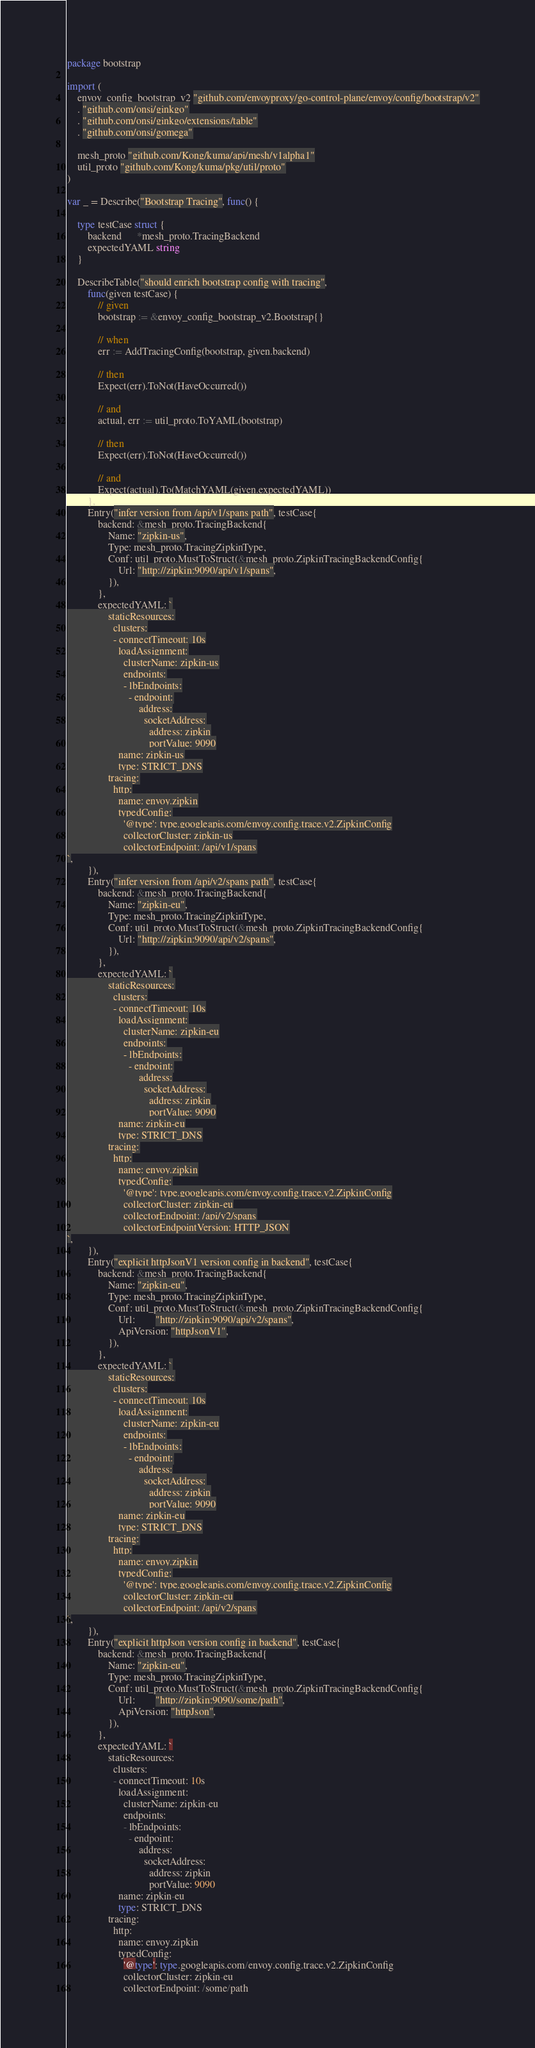Convert code to text. <code><loc_0><loc_0><loc_500><loc_500><_Go_>package bootstrap

import (
	envoy_config_bootstrap_v2 "github.com/envoyproxy/go-control-plane/envoy/config/bootstrap/v2"
	. "github.com/onsi/ginkgo"
	. "github.com/onsi/ginkgo/extensions/table"
	. "github.com/onsi/gomega"

	mesh_proto "github.com/Kong/kuma/api/mesh/v1alpha1"
	util_proto "github.com/Kong/kuma/pkg/util/proto"
)

var _ = Describe("Bootstrap Tracing", func() {

	type testCase struct {
		backend      *mesh_proto.TracingBackend
		expectedYAML string
	}

	DescribeTable("should enrich bootstrap config with tracing",
		func(given testCase) {
			// given
			bootstrap := &envoy_config_bootstrap_v2.Bootstrap{}

			// when
			err := AddTracingConfig(bootstrap, given.backend)

			// then
			Expect(err).ToNot(HaveOccurred())

			// and
			actual, err := util_proto.ToYAML(bootstrap)

			// then
			Expect(err).ToNot(HaveOccurred())

			// and
			Expect(actual).To(MatchYAML(given.expectedYAML))
		},
		Entry("infer version from /api/v1/spans path", testCase{
			backend: &mesh_proto.TracingBackend{
				Name: "zipkin-us",
				Type: mesh_proto.TracingZipkinType,
				Conf: util_proto.MustToStruct(&mesh_proto.ZipkinTracingBackendConfig{
					Url: "http://zipkin:9090/api/v1/spans",
				}),
			},
			expectedYAML: `
                staticResources:
                  clusters:
                  - connectTimeout: 10s
                    loadAssignment:
                      clusterName: zipkin-us
                      endpoints:
                      - lbEndpoints:
                        - endpoint:
                            address:
                              socketAddress:
                                address: zipkin
                                portValue: 9090
                    name: zipkin-us
                    type: STRICT_DNS
                tracing:
                  http:
                    name: envoy.zipkin
                    typedConfig:
                      '@type': type.googleapis.com/envoy.config.trace.v2.ZipkinConfig
                      collectorCluster: zipkin-us
                      collectorEndpoint: /api/v1/spans
`,
		}),
		Entry("infer version from /api/v2/spans path", testCase{
			backend: &mesh_proto.TracingBackend{
				Name: "zipkin-eu",
				Type: mesh_proto.TracingZipkinType,
				Conf: util_proto.MustToStruct(&mesh_proto.ZipkinTracingBackendConfig{
					Url: "http://zipkin:9090/api/v2/spans",
				}),
			},
			expectedYAML: `
                staticResources:
                  clusters:
                  - connectTimeout: 10s
                    loadAssignment:
                      clusterName: zipkin-eu
                      endpoints:
                      - lbEndpoints:
                        - endpoint:
                            address:
                              socketAddress:
                                address: zipkin
                                portValue: 9090
                    name: zipkin-eu
                    type: STRICT_DNS
                tracing:
                  http:
                    name: envoy.zipkin
                    typedConfig:
                      '@type': type.googleapis.com/envoy.config.trace.v2.ZipkinConfig
                      collectorCluster: zipkin-eu
                      collectorEndpoint: /api/v2/spans
                      collectorEndpointVersion: HTTP_JSON
`,
		}),
		Entry("explicit httpJsonV1 version config in backend", testCase{
			backend: &mesh_proto.TracingBackend{
				Name: "zipkin-eu",
				Type: mesh_proto.TracingZipkinType,
				Conf: util_proto.MustToStruct(&mesh_proto.ZipkinTracingBackendConfig{
					Url:        "http://zipkin:9090/api/v2/spans",
					ApiVersion: "httpJsonV1",
				}),
			},
			expectedYAML: `
                staticResources:
                  clusters:
                  - connectTimeout: 10s
                    loadAssignment:
                      clusterName: zipkin-eu
                      endpoints:
                      - lbEndpoints:
                        - endpoint:
                            address:
                              socketAddress:
                                address: zipkin
                                portValue: 9090
                    name: zipkin-eu
                    type: STRICT_DNS
                tracing:
                  http:
                    name: envoy.zipkin
                    typedConfig:
                      '@type': type.googleapis.com/envoy.config.trace.v2.ZipkinConfig
                      collectorCluster: zipkin-eu
                      collectorEndpoint: /api/v2/spans
`,
		}),
		Entry("explicit httpJson version config in backend", testCase{
			backend: &mesh_proto.TracingBackend{
				Name: "zipkin-eu",
				Type: mesh_proto.TracingZipkinType,
				Conf: util_proto.MustToStruct(&mesh_proto.ZipkinTracingBackendConfig{
					Url:        "http://zipkin:9090/some/path",
					ApiVersion: "httpJson",
				}),
			},
			expectedYAML: `
                staticResources:
                  clusters:
                  - connectTimeout: 10s
                    loadAssignment:
                      clusterName: zipkin-eu
                      endpoints:
                      - lbEndpoints:
                        - endpoint:
                            address:
                              socketAddress:
                                address: zipkin
                                portValue: 9090
                    name: zipkin-eu
                    type: STRICT_DNS
                tracing:
                  http:
                    name: envoy.zipkin
                    typedConfig:
                      '@type': type.googleapis.com/envoy.config.trace.v2.ZipkinConfig
                      collectorCluster: zipkin-eu
                      collectorEndpoint: /some/path</code> 